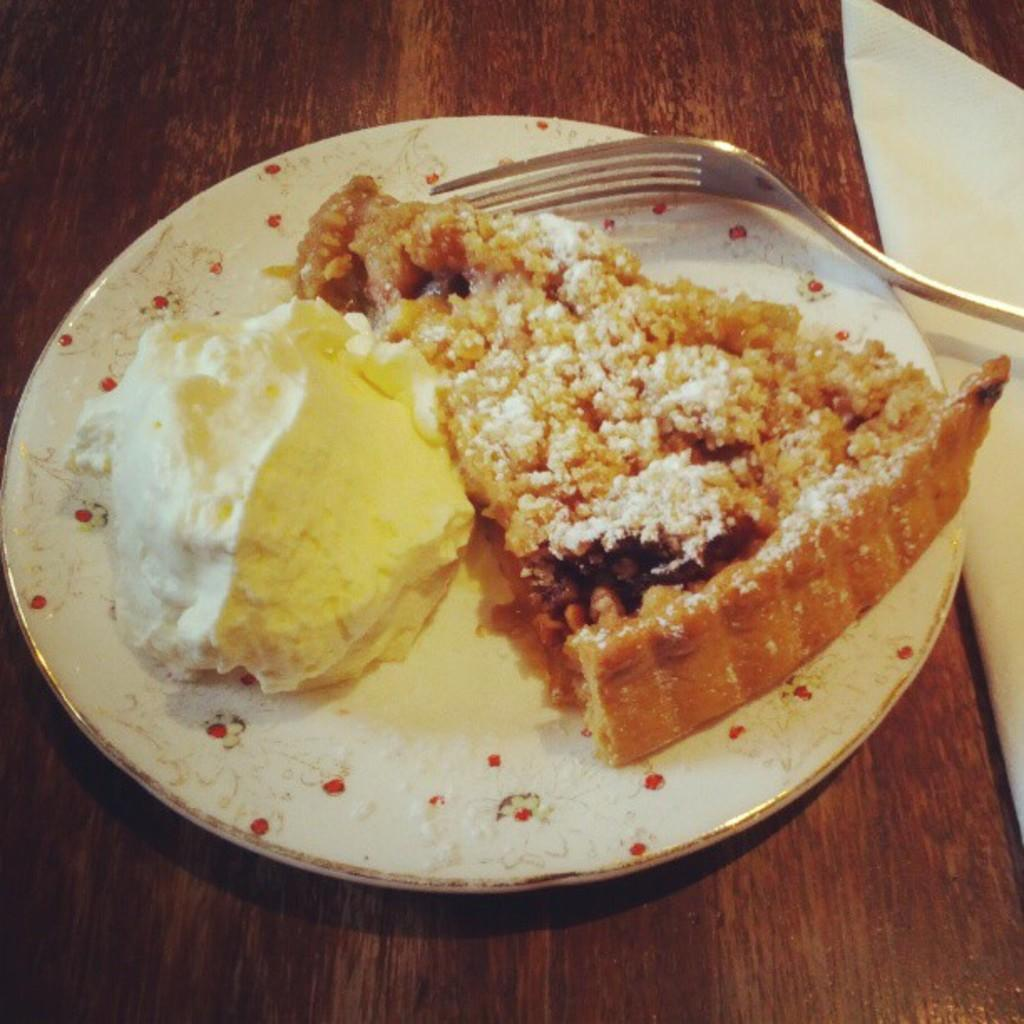What is on the serving plate in the image? The serving plate contains desserts. What utensil is present on the serving plate? There is a fork on the serving plate. What can be seen in the background of the image? There is a table and a paper napkin in the background of the image. What type of government is depicted on the desserts in the image? There is no government depicted on the desserts in the image; they are simply desserts on a serving plate. 